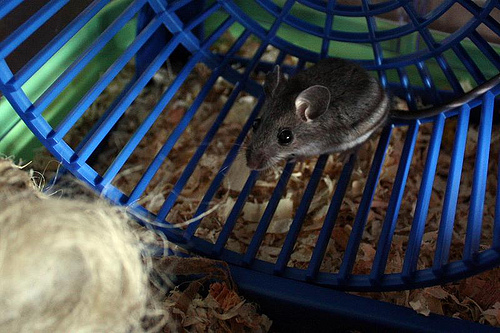<image>
Is the rod in the rat? No. The rod is not contained within the rat. These objects have a different spatial relationship. 